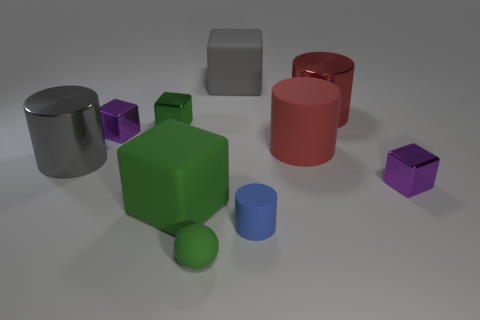How many small green cubes are in front of the big red rubber thing?
Your answer should be very brief. 0. The block right of the cylinder that is behind the green shiny cube is what color?
Ensure brevity in your answer.  Purple. Is there anything else that has the same shape as the small blue thing?
Keep it short and to the point. Yes. Are there the same number of big matte blocks on the right side of the small rubber ball and big gray cylinders right of the gray metallic cylinder?
Make the answer very short. No. How many cylinders are either red objects or gray metal things?
Provide a succinct answer. 3. What number of other objects are there of the same material as the tiny cylinder?
Provide a short and direct response. 4. There is a large red thing that is in front of the green metal object; what shape is it?
Your answer should be very brief. Cylinder. The small green thing that is behind the metallic cylinder left of the big gray cube is made of what material?
Offer a terse response. Metal. Are there more purple objects that are on the right side of the green metallic thing than small shiny cubes?
Give a very brief answer. No. How many other things are the same color as the small sphere?
Your answer should be compact. 2. 